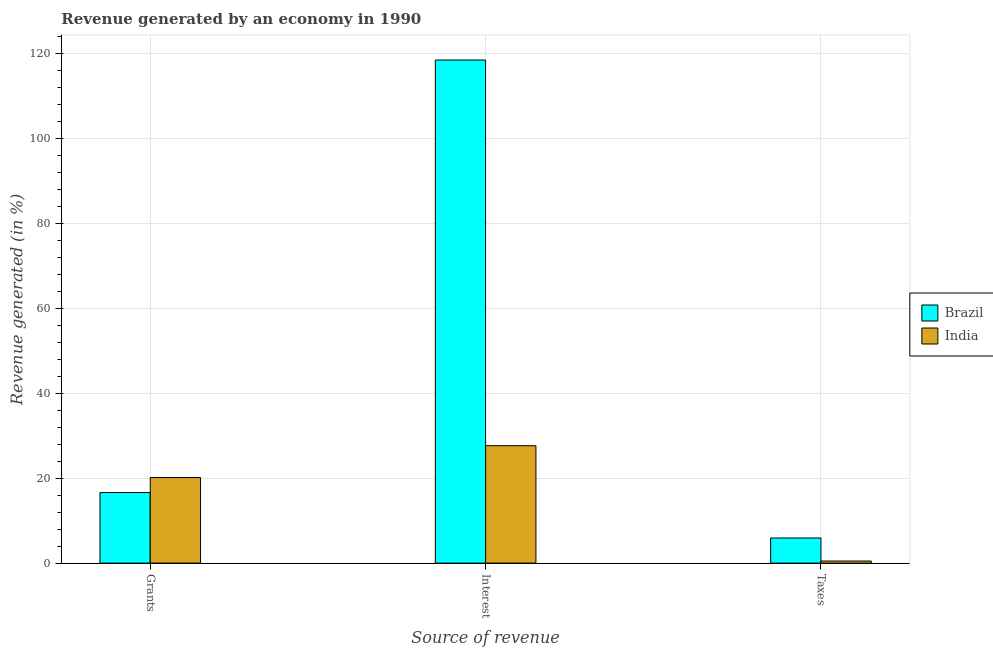How many different coloured bars are there?
Your answer should be very brief. 2. How many groups of bars are there?
Offer a very short reply. 3. How many bars are there on the 2nd tick from the left?
Offer a very short reply. 2. What is the label of the 1st group of bars from the left?
Keep it short and to the point. Grants. What is the percentage of revenue generated by grants in India?
Your answer should be very brief. 20.14. Across all countries, what is the maximum percentage of revenue generated by interest?
Your answer should be very brief. 118.44. Across all countries, what is the minimum percentage of revenue generated by interest?
Give a very brief answer. 27.64. In which country was the percentage of revenue generated by grants minimum?
Your answer should be compact. Brazil. What is the total percentage of revenue generated by interest in the graph?
Provide a succinct answer. 146.08. What is the difference between the percentage of revenue generated by interest in India and that in Brazil?
Provide a succinct answer. -90.8. What is the difference between the percentage of revenue generated by interest in India and the percentage of revenue generated by grants in Brazil?
Ensure brevity in your answer.  11.03. What is the average percentage of revenue generated by interest per country?
Offer a very short reply. 73.04. What is the difference between the percentage of revenue generated by taxes and percentage of revenue generated by interest in India?
Your response must be concise. -27.15. In how many countries, is the percentage of revenue generated by grants greater than 80 %?
Keep it short and to the point. 0. What is the ratio of the percentage of revenue generated by interest in India to that in Brazil?
Give a very brief answer. 0.23. What is the difference between the highest and the second highest percentage of revenue generated by interest?
Your response must be concise. 90.8. What is the difference between the highest and the lowest percentage of revenue generated by interest?
Provide a succinct answer. 90.8. In how many countries, is the percentage of revenue generated by interest greater than the average percentage of revenue generated by interest taken over all countries?
Your response must be concise. 1. Is the sum of the percentage of revenue generated by interest in Brazil and India greater than the maximum percentage of revenue generated by grants across all countries?
Provide a short and direct response. Yes. What does the 2nd bar from the left in Grants represents?
Offer a very short reply. India. Is it the case that in every country, the sum of the percentage of revenue generated by grants and percentage of revenue generated by interest is greater than the percentage of revenue generated by taxes?
Keep it short and to the point. Yes. How many bars are there?
Ensure brevity in your answer.  6. How many countries are there in the graph?
Your answer should be very brief. 2. Are the values on the major ticks of Y-axis written in scientific E-notation?
Make the answer very short. No. Does the graph contain grids?
Your answer should be very brief. Yes. What is the title of the graph?
Your response must be concise. Revenue generated by an economy in 1990. What is the label or title of the X-axis?
Give a very brief answer. Source of revenue. What is the label or title of the Y-axis?
Make the answer very short. Revenue generated (in %). What is the Revenue generated (in %) in Brazil in Grants?
Give a very brief answer. 16.61. What is the Revenue generated (in %) in India in Grants?
Keep it short and to the point. 20.14. What is the Revenue generated (in %) of Brazil in Interest?
Keep it short and to the point. 118.44. What is the Revenue generated (in %) in India in Interest?
Ensure brevity in your answer.  27.64. What is the Revenue generated (in %) in Brazil in Taxes?
Provide a short and direct response. 5.91. What is the Revenue generated (in %) of India in Taxes?
Offer a terse response. 0.49. Across all Source of revenue, what is the maximum Revenue generated (in %) of Brazil?
Ensure brevity in your answer.  118.44. Across all Source of revenue, what is the maximum Revenue generated (in %) of India?
Provide a short and direct response. 27.64. Across all Source of revenue, what is the minimum Revenue generated (in %) of Brazil?
Keep it short and to the point. 5.91. Across all Source of revenue, what is the minimum Revenue generated (in %) of India?
Provide a succinct answer. 0.49. What is the total Revenue generated (in %) of Brazil in the graph?
Your response must be concise. 140.97. What is the total Revenue generated (in %) in India in the graph?
Ensure brevity in your answer.  48.27. What is the difference between the Revenue generated (in %) of Brazil in Grants and that in Interest?
Provide a succinct answer. -101.83. What is the difference between the Revenue generated (in %) in India in Grants and that in Interest?
Make the answer very short. -7.5. What is the difference between the Revenue generated (in %) of Brazil in Grants and that in Taxes?
Your answer should be very brief. 10.7. What is the difference between the Revenue generated (in %) of India in Grants and that in Taxes?
Ensure brevity in your answer.  19.65. What is the difference between the Revenue generated (in %) of Brazil in Interest and that in Taxes?
Keep it short and to the point. 112.53. What is the difference between the Revenue generated (in %) in India in Interest and that in Taxes?
Give a very brief answer. 27.15. What is the difference between the Revenue generated (in %) of Brazil in Grants and the Revenue generated (in %) of India in Interest?
Keep it short and to the point. -11.03. What is the difference between the Revenue generated (in %) of Brazil in Grants and the Revenue generated (in %) of India in Taxes?
Your answer should be compact. 16.12. What is the difference between the Revenue generated (in %) of Brazil in Interest and the Revenue generated (in %) of India in Taxes?
Keep it short and to the point. 117.95. What is the average Revenue generated (in %) in Brazil per Source of revenue?
Give a very brief answer. 46.99. What is the average Revenue generated (in %) of India per Source of revenue?
Offer a very short reply. 16.09. What is the difference between the Revenue generated (in %) in Brazil and Revenue generated (in %) in India in Grants?
Provide a short and direct response. -3.53. What is the difference between the Revenue generated (in %) of Brazil and Revenue generated (in %) of India in Interest?
Your response must be concise. 90.8. What is the difference between the Revenue generated (in %) of Brazil and Revenue generated (in %) of India in Taxes?
Your answer should be very brief. 5.42. What is the ratio of the Revenue generated (in %) of Brazil in Grants to that in Interest?
Provide a succinct answer. 0.14. What is the ratio of the Revenue generated (in %) of India in Grants to that in Interest?
Your answer should be very brief. 0.73. What is the ratio of the Revenue generated (in %) in Brazil in Grants to that in Taxes?
Ensure brevity in your answer.  2.81. What is the ratio of the Revenue generated (in %) of India in Grants to that in Taxes?
Your answer should be compact. 40.83. What is the ratio of the Revenue generated (in %) in Brazil in Interest to that in Taxes?
Your response must be concise. 20.03. What is the ratio of the Revenue generated (in %) of India in Interest to that in Taxes?
Ensure brevity in your answer.  56.03. What is the difference between the highest and the second highest Revenue generated (in %) in Brazil?
Give a very brief answer. 101.83. What is the difference between the highest and the second highest Revenue generated (in %) of India?
Give a very brief answer. 7.5. What is the difference between the highest and the lowest Revenue generated (in %) of Brazil?
Provide a succinct answer. 112.53. What is the difference between the highest and the lowest Revenue generated (in %) of India?
Provide a short and direct response. 27.15. 